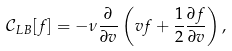<formula> <loc_0><loc_0><loc_500><loc_500>\mathcal { C } _ { L B } [ f ] = - \nu \frac { \partial } { \partial v } \left ( v f + \frac { 1 } { 2 } \frac { \partial f } { \partial v } \right ) ,</formula> 